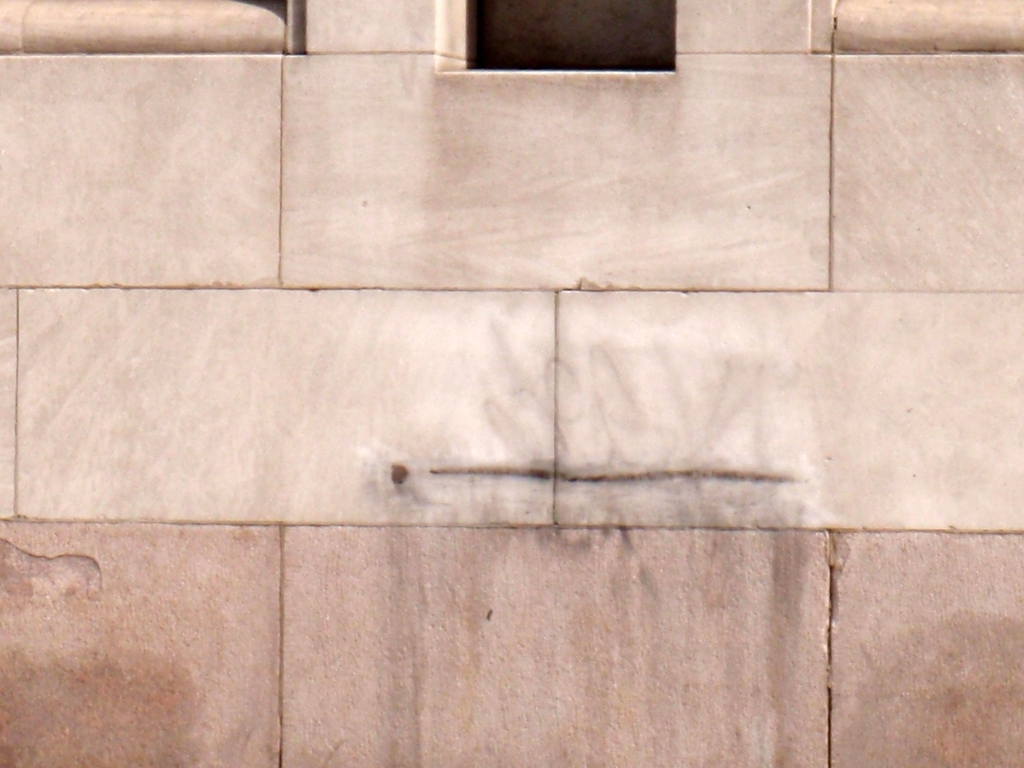What is the significance of the faint marking on the wall? The faint marking appears to be a form of graffiti, which often serves as a means of self-expression or public commentary. However, due to its lack of clarity and context within the image, it is difficult to ascribe a specific meaning to this particular marking without additional information.  Can you tell me more about the wall's condition? Certainly! The wall in the image displays signs of wear and age, with discoloration in certain areas, which may suggest prolonged exposure to the elements. Additionally, the visible sediment or mineral deposit streaks could indicate that there has been water runoff over the surface at some point. 